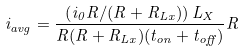<formula> <loc_0><loc_0><loc_500><loc_500>i _ { a v g } = \frac { \left ( i _ { 0 } R / ( R + R _ { L x } ) \right ) L _ { X } } { R ( R + R _ { L x } ) ( t _ { o n } + t _ { o f f } ) } R</formula> 